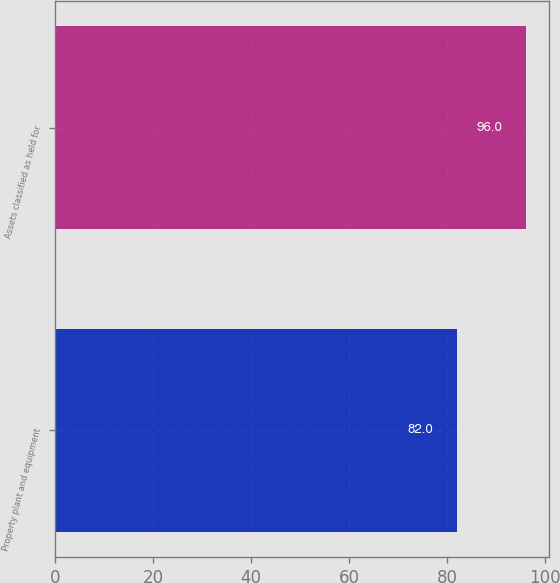Convert chart to OTSL. <chart><loc_0><loc_0><loc_500><loc_500><bar_chart><fcel>Property plant and equipment<fcel>Assets classified as held for<nl><fcel>82<fcel>96<nl></chart> 